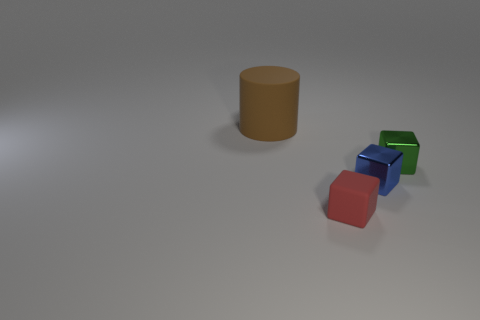Add 1 green metallic things. How many objects exist? 5 Subtract all cylinders. How many objects are left? 3 Subtract all blue cylinders. Subtract all small matte blocks. How many objects are left? 3 Add 1 small red blocks. How many small red blocks are left? 2 Add 1 tiny cubes. How many tiny cubes exist? 4 Subtract 0 brown blocks. How many objects are left? 4 